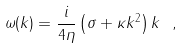<formula> <loc_0><loc_0><loc_500><loc_500>\omega ( k ) = \frac { i } { 4 \eta } \left ( \sigma + \kappa k ^ { 2 } \right ) k \ ,</formula> 